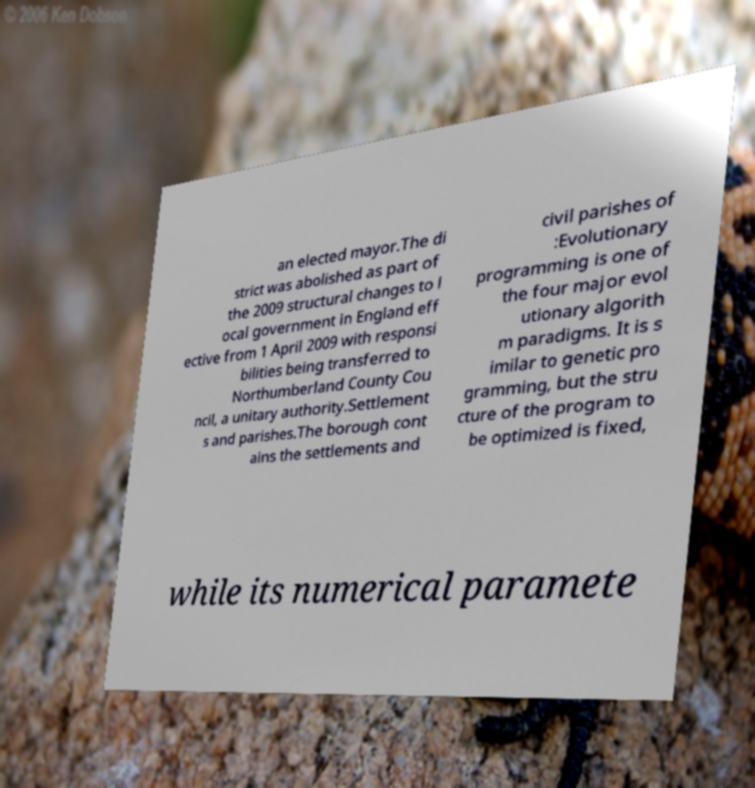Could you extract and type out the text from this image? an elected mayor.The di strict was abolished as part of the 2009 structural changes to l ocal government in England eff ective from 1 April 2009 with responsi bilities being transferred to Northumberland County Cou ncil, a unitary authority.Settlement s and parishes.The borough cont ains the settlements and civil parishes of :Evolutionary programming is one of the four major evol utionary algorith m paradigms. It is s imilar to genetic pro gramming, but the stru cture of the program to be optimized is fixed, while its numerical paramete 